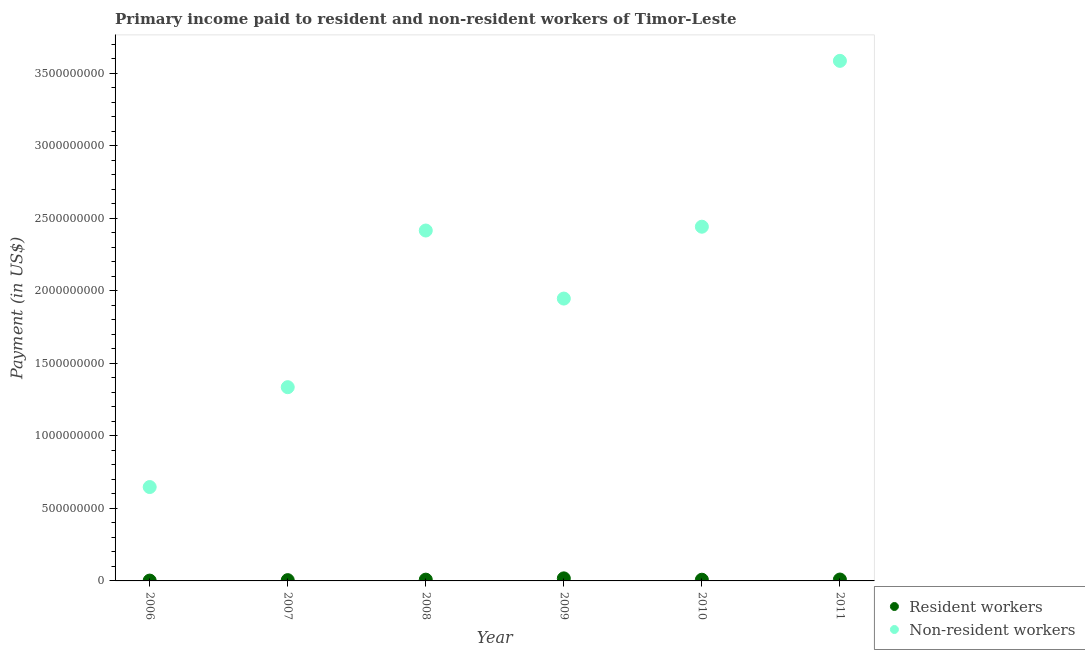What is the payment made to resident workers in 2008?
Provide a succinct answer. 8.81e+06. Across all years, what is the maximum payment made to resident workers?
Keep it short and to the point. 1.76e+07. Across all years, what is the minimum payment made to non-resident workers?
Give a very brief answer. 6.48e+08. In which year was the payment made to resident workers minimum?
Ensure brevity in your answer.  2006. What is the total payment made to resident workers in the graph?
Offer a terse response. 5.21e+07. What is the difference between the payment made to resident workers in 2006 and that in 2009?
Ensure brevity in your answer.  -1.53e+07. What is the difference between the payment made to non-resident workers in 2006 and the payment made to resident workers in 2009?
Make the answer very short. 6.30e+08. What is the average payment made to non-resident workers per year?
Ensure brevity in your answer.  2.06e+09. In the year 2011, what is the difference between the payment made to resident workers and payment made to non-resident workers?
Make the answer very short. -3.58e+09. In how many years, is the payment made to non-resident workers greater than 2800000000 US$?
Your answer should be compact. 1. What is the ratio of the payment made to resident workers in 2006 to that in 2009?
Ensure brevity in your answer.  0.13. Is the difference between the payment made to non-resident workers in 2006 and 2011 greater than the difference between the payment made to resident workers in 2006 and 2011?
Offer a very short reply. No. What is the difference between the highest and the second highest payment made to resident workers?
Ensure brevity in your answer.  8.02e+06. What is the difference between the highest and the lowest payment made to resident workers?
Provide a succinct answer. 1.53e+07. Is the sum of the payment made to non-resident workers in 2008 and 2010 greater than the maximum payment made to resident workers across all years?
Ensure brevity in your answer.  Yes. Does the payment made to resident workers monotonically increase over the years?
Offer a terse response. No. How many dotlines are there?
Keep it short and to the point. 2. How many years are there in the graph?
Your response must be concise. 6. Are the values on the major ticks of Y-axis written in scientific E-notation?
Provide a short and direct response. No. Does the graph contain any zero values?
Your answer should be very brief. No. Where does the legend appear in the graph?
Provide a short and direct response. Bottom right. How many legend labels are there?
Give a very brief answer. 2. What is the title of the graph?
Your answer should be very brief. Primary income paid to resident and non-resident workers of Timor-Leste. What is the label or title of the X-axis?
Offer a terse response. Year. What is the label or title of the Y-axis?
Keep it short and to the point. Payment (in US$). What is the Payment (in US$) in Resident workers in 2006?
Keep it short and to the point. 2.34e+06. What is the Payment (in US$) in Non-resident workers in 2006?
Give a very brief answer. 6.48e+08. What is the Payment (in US$) of Resident workers in 2007?
Make the answer very short. 5.40e+06. What is the Payment (in US$) of Non-resident workers in 2007?
Provide a short and direct response. 1.34e+09. What is the Payment (in US$) of Resident workers in 2008?
Offer a very short reply. 8.81e+06. What is the Payment (in US$) in Non-resident workers in 2008?
Your response must be concise. 2.42e+09. What is the Payment (in US$) of Resident workers in 2009?
Your response must be concise. 1.76e+07. What is the Payment (in US$) of Non-resident workers in 2009?
Ensure brevity in your answer.  1.95e+09. What is the Payment (in US$) of Resident workers in 2010?
Provide a succinct answer. 8.26e+06. What is the Payment (in US$) in Non-resident workers in 2010?
Provide a succinct answer. 2.44e+09. What is the Payment (in US$) of Resident workers in 2011?
Give a very brief answer. 9.62e+06. What is the Payment (in US$) in Non-resident workers in 2011?
Your response must be concise. 3.59e+09. Across all years, what is the maximum Payment (in US$) in Resident workers?
Your answer should be compact. 1.76e+07. Across all years, what is the maximum Payment (in US$) in Non-resident workers?
Ensure brevity in your answer.  3.59e+09. Across all years, what is the minimum Payment (in US$) of Resident workers?
Your answer should be compact. 2.34e+06. Across all years, what is the minimum Payment (in US$) in Non-resident workers?
Provide a short and direct response. 6.48e+08. What is the total Payment (in US$) of Resident workers in the graph?
Your answer should be compact. 5.21e+07. What is the total Payment (in US$) in Non-resident workers in the graph?
Offer a very short reply. 1.24e+1. What is the difference between the Payment (in US$) of Resident workers in 2006 and that in 2007?
Provide a succinct answer. -3.06e+06. What is the difference between the Payment (in US$) in Non-resident workers in 2006 and that in 2007?
Offer a very short reply. -6.89e+08. What is the difference between the Payment (in US$) of Resident workers in 2006 and that in 2008?
Provide a succinct answer. -6.47e+06. What is the difference between the Payment (in US$) in Non-resident workers in 2006 and that in 2008?
Make the answer very short. -1.77e+09. What is the difference between the Payment (in US$) of Resident workers in 2006 and that in 2009?
Keep it short and to the point. -1.53e+07. What is the difference between the Payment (in US$) in Non-resident workers in 2006 and that in 2009?
Provide a short and direct response. -1.30e+09. What is the difference between the Payment (in US$) in Resident workers in 2006 and that in 2010?
Your answer should be compact. -5.92e+06. What is the difference between the Payment (in US$) in Non-resident workers in 2006 and that in 2010?
Provide a short and direct response. -1.80e+09. What is the difference between the Payment (in US$) of Resident workers in 2006 and that in 2011?
Offer a very short reply. -7.28e+06. What is the difference between the Payment (in US$) in Non-resident workers in 2006 and that in 2011?
Make the answer very short. -2.94e+09. What is the difference between the Payment (in US$) in Resident workers in 2007 and that in 2008?
Provide a succinct answer. -3.41e+06. What is the difference between the Payment (in US$) in Non-resident workers in 2007 and that in 2008?
Offer a very short reply. -1.08e+09. What is the difference between the Payment (in US$) in Resident workers in 2007 and that in 2009?
Provide a succinct answer. -1.22e+07. What is the difference between the Payment (in US$) of Non-resident workers in 2007 and that in 2009?
Keep it short and to the point. -6.11e+08. What is the difference between the Payment (in US$) in Resident workers in 2007 and that in 2010?
Your response must be concise. -2.86e+06. What is the difference between the Payment (in US$) in Non-resident workers in 2007 and that in 2010?
Your answer should be very brief. -1.11e+09. What is the difference between the Payment (in US$) in Resident workers in 2007 and that in 2011?
Keep it short and to the point. -4.22e+06. What is the difference between the Payment (in US$) in Non-resident workers in 2007 and that in 2011?
Provide a short and direct response. -2.25e+09. What is the difference between the Payment (in US$) of Resident workers in 2008 and that in 2009?
Your answer should be compact. -8.83e+06. What is the difference between the Payment (in US$) of Non-resident workers in 2008 and that in 2009?
Ensure brevity in your answer.  4.69e+08. What is the difference between the Payment (in US$) in Resident workers in 2008 and that in 2010?
Offer a terse response. 5.47e+05. What is the difference between the Payment (in US$) of Non-resident workers in 2008 and that in 2010?
Your response must be concise. -2.63e+07. What is the difference between the Payment (in US$) in Resident workers in 2008 and that in 2011?
Your response must be concise. -8.12e+05. What is the difference between the Payment (in US$) in Non-resident workers in 2008 and that in 2011?
Provide a short and direct response. -1.17e+09. What is the difference between the Payment (in US$) in Resident workers in 2009 and that in 2010?
Your answer should be very brief. 9.38e+06. What is the difference between the Payment (in US$) of Non-resident workers in 2009 and that in 2010?
Keep it short and to the point. -4.96e+08. What is the difference between the Payment (in US$) in Resident workers in 2009 and that in 2011?
Offer a very short reply. 8.02e+06. What is the difference between the Payment (in US$) in Non-resident workers in 2009 and that in 2011?
Provide a short and direct response. -1.64e+09. What is the difference between the Payment (in US$) in Resident workers in 2010 and that in 2011?
Make the answer very short. -1.36e+06. What is the difference between the Payment (in US$) in Non-resident workers in 2010 and that in 2011?
Offer a very short reply. -1.14e+09. What is the difference between the Payment (in US$) in Resident workers in 2006 and the Payment (in US$) in Non-resident workers in 2007?
Offer a terse response. -1.33e+09. What is the difference between the Payment (in US$) in Resident workers in 2006 and the Payment (in US$) in Non-resident workers in 2008?
Give a very brief answer. -2.41e+09. What is the difference between the Payment (in US$) in Resident workers in 2006 and the Payment (in US$) in Non-resident workers in 2009?
Provide a succinct answer. -1.95e+09. What is the difference between the Payment (in US$) of Resident workers in 2006 and the Payment (in US$) of Non-resident workers in 2010?
Your answer should be very brief. -2.44e+09. What is the difference between the Payment (in US$) in Resident workers in 2006 and the Payment (in US$) in Non-resident workers in 2011?
Offer a very short reply. -3.58e+09. What is the difference between the Payment (in US$) in Resident workers in 2007 and the Payment (in US$) in Non-resident workers in 2008?
Provide a succinct answer. -2.41e+09. What is the difference between the Payment (in US$) of Resident workers in 2007 and the Payment (in US$) of Non-resident workers in 2009?
Provide a short and direct response. -1.94e+09. What is the difference between the Payment (in US$) in Resident workers in 2007 and the Payment (in US$) in Non-resident workers in 2010?
Give a very brief answer. -2.44e+09. What is the difference between the Payment (in US$) in Resident workers in 2007 and the Payment (in US$) in Non-resident workers in 2011?
Offer a very short reply. -3.58e+09. What is the difference between the Payment (in US$) of Resident workers in 2008 and the Payment (in US$) of Non-resident workers in 2009?
Provide a succinct answer. -1.94e+09. What is the difference between the Payment (in US$) of Resident workers in 2008 and the Payment (in US$) of Non-resident workers in 2010?
Give a very brief answer. -2.43e+09. What is the difference between the Payment (in US$) in Resident workers in 2008 and the Payment (in US$) in Non-resident workers in 2011?
Ensure brevity in your answer.  -3.58e+09. What is the difference between the Payment (in US$) in Resident workers in 2009 and the Payment (in US$) in Non-resident workers in 2010?
Provide a short and direct response. -2.43e+09. What is the difference between the Payment (in US$) in Resident workers in 2009 and the Payment (in US$) in Non-resident workers in 2011?
Your response must be concise. -3.57e+09. What is the difference between the Payment (in US$) of Resident workers in 2010 and the Payment (in US$) of Non-resident workers in 2011?
Offer a very short reply. -3.58e+09. What is the average Payment (in US$) of Resident workers per year?
Your answer should be very brief. 8.68e+06. What is the average Payment (in US$) of Non-resident workers per year?
Keep it short and to the point. 2.06e+09. In the year 2006, what is the difference between the Payment (in US$) of Resident workers and Payment (in US$) of Non-resident workers?
Your answer should be very brief. -6.45e+08. In the year 2007, what is the difference between the Payment (in US$) of Resident workers and Payment (in US$) of Non-resident workers?
Make the answer very short. -1.33e+09. In the year 2008, what is the difference between the Payment (in US$) in Resident workers and Payment (in US$) in Non-resident workers?
Ensure brevity in your answer.  -2.41e+09. In the year 2009, what is the difference between the Payment (in US$) in Resident workers and Payment (in US$) in Non-resident workers?
Provide a short and direct response. -1.93e+09. In the year 2010, what is the difference between the Payment (in US$) of Resident workers and Payment (in US$) of Non-resident workers?
Provide a succinct answer. -2.43e+09. In the year 2011, what is the difference between the Payment (in US$) in Resident workers and Payment (in US$) in Non-resident workers?
Give a very brief answer. -3.58e+09. What is the ratio of the Payment (in US$) of Resident workers in 2006 to that in 2007?
Your response must be concise. 0.43. What is the ratio of the Payment (in US$) of Non-resident workers in 2006 to that in 2007?
Your answer should be compact. 0.48. What is the ratio of the Payment (in US$) in Resident workers in 2006 to that in 2008?
Offer a terse response. 0.27. What is the ratio of the Payment (in US$) in Non-resident workers in 2006 to that in 2008?
Your answer should be compact. 0.27. What is the ratio of the Payment (in US$) of Resident workers in 2006 to that in 2009?
Give a very brief answer. 0.13. What is the ratio of the Payment (in US$) of Non-resident workers in 2006 to that in 2009?
Make the answer very short. 0.33. What is the ratio of the Payment (in US$) of Resident workers in 2006 to that in 2010?
Ensure brevity in your answer.  0.28. What is the ratio of the Payment (in US$) of Non-resident workers in 2006 to that in 2010?
Your response must be concise. 0.27. What is the ratio of the Payment (in US$) in Resident workers in 2006 to that in 2011?
Provide a short and direct response. 0.24. What is the ratio of the Payment (in US$) in Non-resident workers in 2006 to that in 2011?
Make the answer very short. 0.18. What is the ratio of the Payment (in US$) in Resident workers in 2007 to that in 2008?
Offer a terse response. 0.61. What is the ratio of the Payment (in US$) in Non-resident workers in 2007 to that in 2008?
Your answer should be very brief. 0.55. What is the ratio of the Payment (in US$) in Resident workers in 2007 to that in 2009?
Your answer should be compact. 0.31. What is the ratio of the Payment (in US$) of Non-resident workers in 2007 to that in 2009?
Make the answer very short. 0.69. What is the ratio of the Payment (in US$) of Resident workers in 2007 to that in 2010?
Your response must be concise. 0.65. What is the ratio of the Payment (in US$) in Non-resident workers in 2007 to that in 2010?
Your answer should be compact. 0.55. What is the ratio of the Payment (in US$) in Resident workers in 2007 to that in 2011?
Your response must be concise. 0.56. What is the ratio of the Payment (in US$) of Non-resident workers in 2007 to that in 2011?
Provide a succinct answer. 0.37. What is the ratio of the Payment (in US$) of Resident workers in 2008 to that in 2009?
Keep it short and to the point. 0.5. What is the ratio of the Payment (in US$) in Non-resident workers in 2008 to that in 2009?
Ensure brevity in your answer.  1.24. What is the ratio of the Payment (in US$) of Resident workers in 2008 to that in 2010?
Give a very brief answer. 1.07. What is the ratio of the Payment (in US$) of Non-resident workers in 2008 to that in 2010?
Give a very brief answer. 0.99. What is the ratio of the Payment (in US$) in Resident workers in 2008 to that in 2011?
Your answer should be very brief. 0.92. What is the ratio of the Payment (in US$) in Non-resident workers in 2008 to that in 2011?
Offer a terse response. 0.67. What is the ratio of the Payment (in US$) in Resident workers in 2009 to that in 2010?
Your answer should be compact. 2.13. What is the ratio of the Payment (in US$) in Non-resident workers in 2009 to that in 2010?
Keep it short and to the point. 0.8. What is the ratio of the Payment (in US$) of Resident workers in 2009 to that in 2011?
Your response must be concise. 1.83. What is the ratio of the Payment (in US$) of Non-resident workers in 2009 to that in 2011?
Offer a very short reply. 0.54. What is the ratio of the Payment (in US$) of Resident workers in 2010 to that in 2011?
Your answer should be compact. 0.86. What is the ratio of the Payment (in US$) in Non-resident workers in 2010 to that in 2011?
Ensure brevity in your answer.  0.68. What is the difference between the highest and the second highest Payment (in US$) of Resident workers?
Offer a terse response. 8.02e+06. What is the difference between the highest and the second highest Payment (in US$) of Non-resident workers?
Keep it short and to the point. 1.14e+09. What is the difference between the highest and the lowest Payment (in US$) in Resident workers?
Provide a succinct answer. 1.53e+07. What is the difference between the highest and the lowest Payment (in US$) of Non-resident workers?
Offer a terse response. 2.94e+09. 